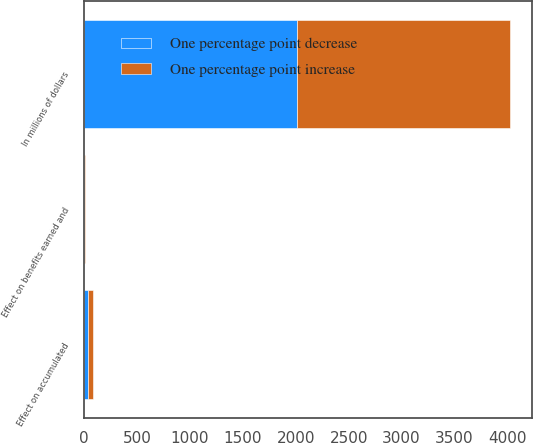Convert chart to OTSL. <chart><loc_0><loc_0><loc_500><loc_500><stacked_bar_chart><ecel><fcel>In millions of dollars<fcel>Effect on benefits earned and<fcel>Effect on accumulated<nl><fcel>One percentage point increase<fcel>2015<fcel>2<fcel>45<nl><fcel>One percentage point decrease<fcel>2015<fcel>2<fcel>38<nl></chart> 